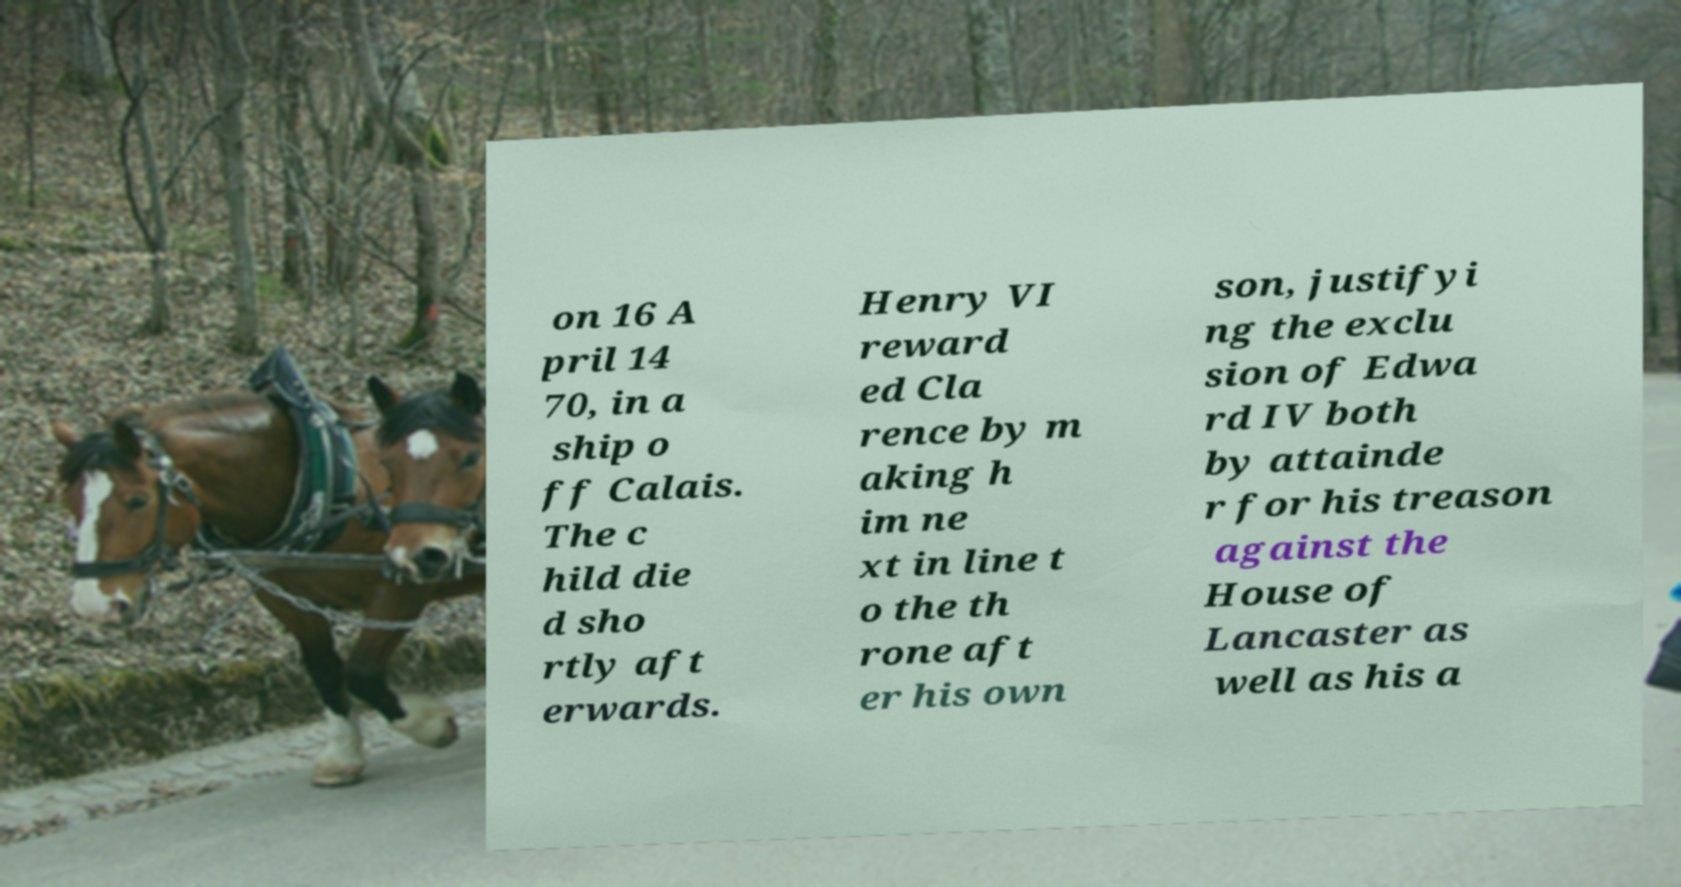For documentation purposes, I need the text within this image transcribed. Could you provide that? on 16 A pril 14 70, in a ship o ff Calais. The c hild die d sho rtly aft erwards. Henry VI reward ed Cla rence by m aking h im ne xt in line t o the th rone aft er his own son, justifyi ng the exclu sion of Edwa rd IV both by attainde r for his treason against the House of Lancaster as well as his a 